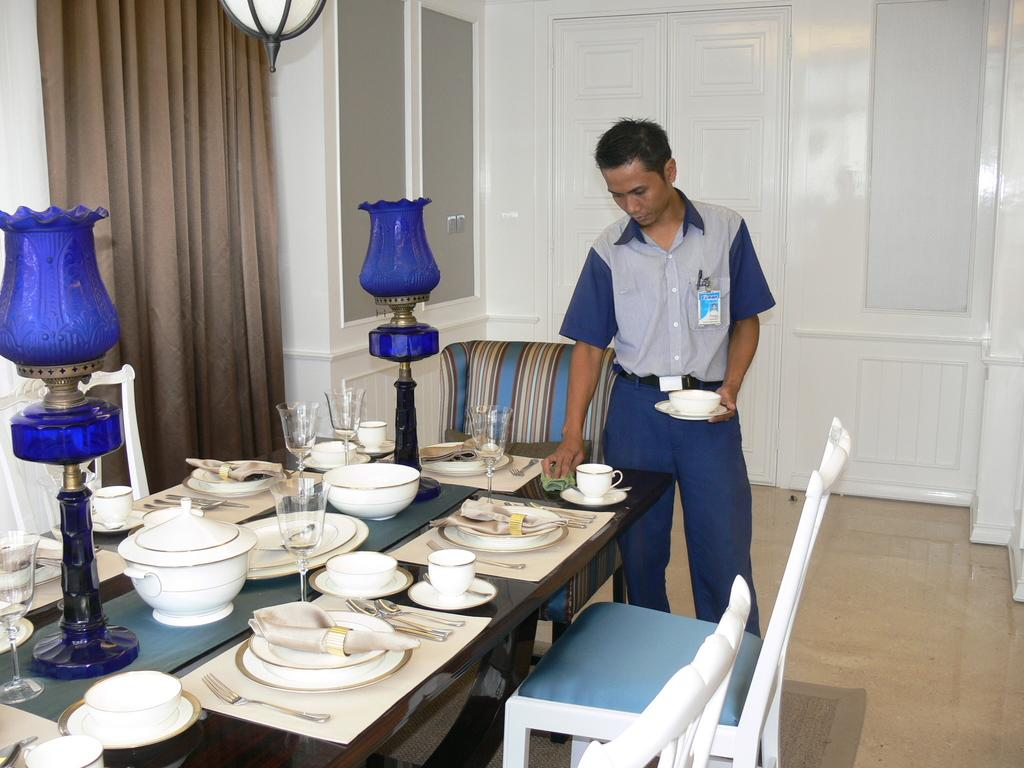What type of structure can be seen in the image? There is a wall in the image. What is hanging near the wall? There is a curtain in the image. What is a common feature found in many rooms that is present in the image? There is a window in the image. What is another common feature found in many rooms that is present in the image? There is a door in the image. What type of furniture is present in the image? There are chairs in the image. Who is present in the image? There is a man standing in the image. What type of furniture is present on which the plates, bowls, cups, and dishes are placed? There is a table in the image. What items can be seen on the table? There are plates, bowls, cups, and dishes on the table. What does the mother believe about the scale in the image? There is no mention of a mother, belief, or scale in the image. 